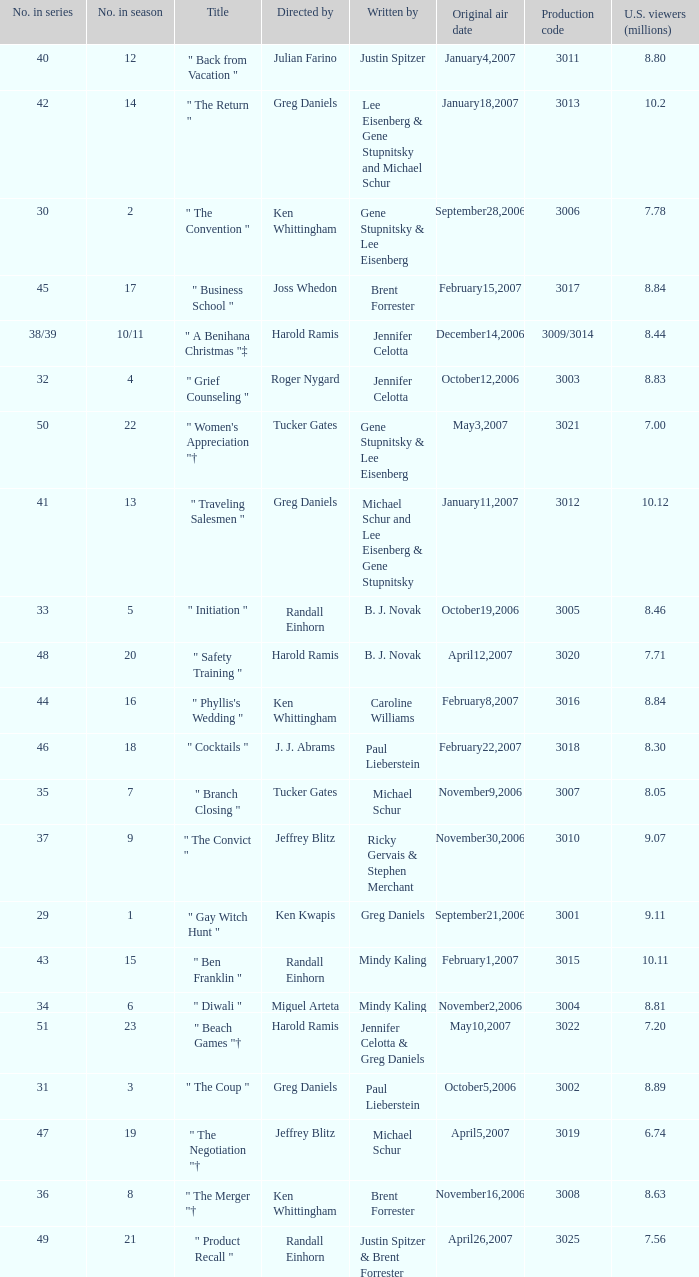Name the total number of titles for 3020 production code 1.0. 